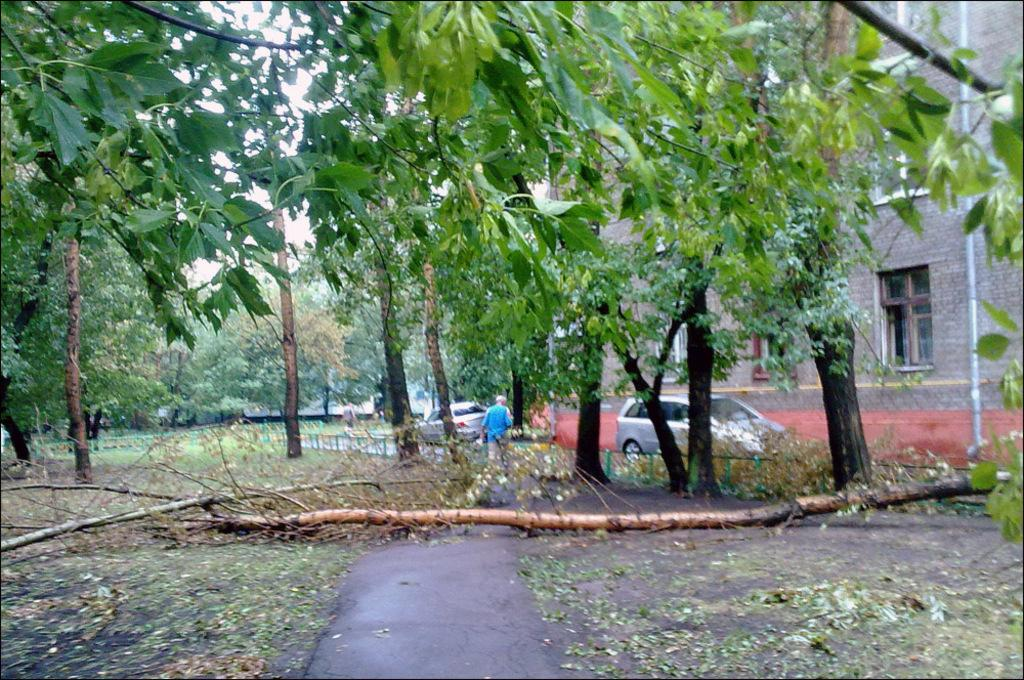What type of vegetation is present in the image? There are huge trees in the image. What can be seen in front of the brown house? There is a car parked in front of the brown house. What part of the image shows the ground area? The ground area is visible in the front bottom side of the image. What type of adjustment can be seen on the car's suspension in the image? There is no mention of any adjustment to the car's suspension in the image. What type of air is present in the image? The image does not depict any specific type of air. 